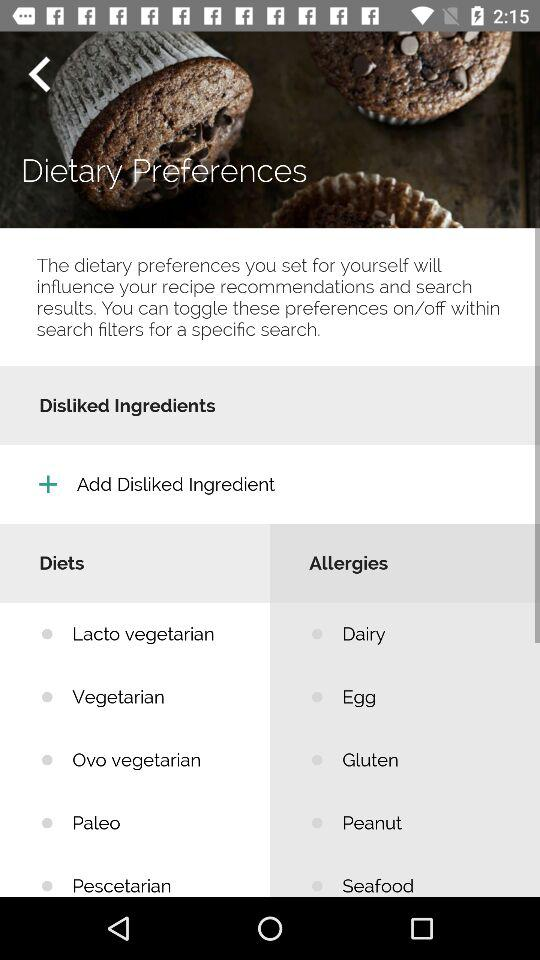What are the products that cause allergies? The products are dairy, egg, gluten, peanut and seafood. 